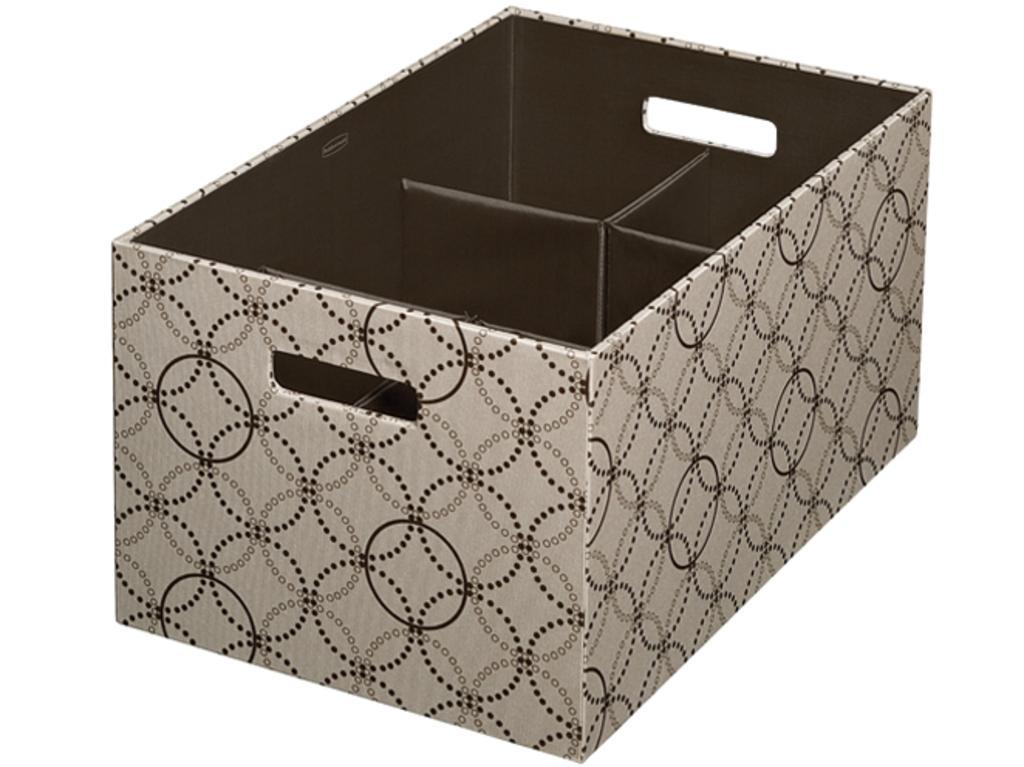How would you summarize this image in a sentence or two? In this picture I can observe a box. This box is in grey and brown color. The background is in white color. 